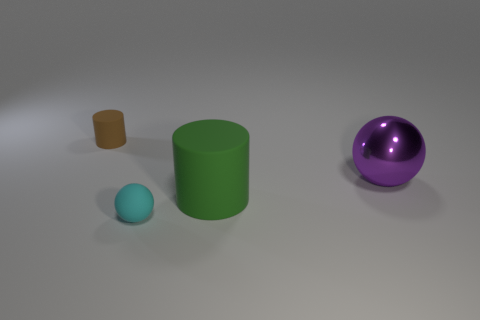There is a rubber cylinder that is in front of the purple ball; is its size the same as the small brown rubber cylinder?
Keep it short and to the point. No. Is there a big cylinder that has the same color as the shiny ball?
Offer a terse response. No. Are there any big cylinders that are behind the sphere that is in front of the purple shiny thing?
Provide a succinct answer. Yes. Are there any yellow objects made of the same material as the green cylinder?
Provide a short and direct response. No. There is a brown cylinder that is left of the cylinder in front of the big metal thing; what is its material?
Provide a succinct answer. Rubber. There is a thing that is both on the left side of the big cylinder and in front of the large purple shiny sphere; what material is it made of?
Give a very brief answer. Rubber. Are there an equal number of large metallic balls that are left of the big purple object and green cylinders?
Provide a succinct answer. No. What number of tiny rubber things have the same shape as the large matte object?
Your answer should be very brief. 1. There is a sphere left of the rubber cylinder that is on the right side of the tiny rubber object that is behind the green cylinder; what size is it?
Ensure brevity in your answer.  Small. Is the sphere that is to the left of the purple ball made of the same material as the big green object?
Give a very brief answer. Yes. 